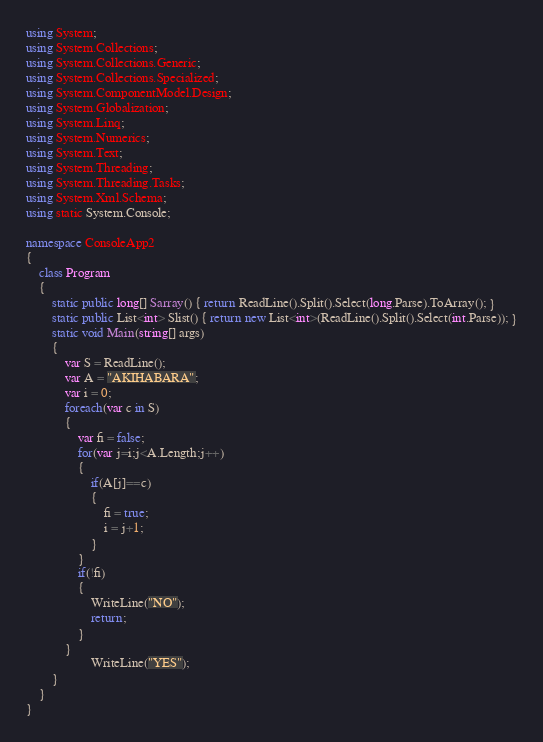<code> <loc_0><loc_0><loc_500><loc_500><_C#_>using System;
using System.Collections;
using System.Collections.Generic;
using System.Collections.Specialized;
using System.ComponentModel.Design;
using System.Globalization;
using System.Linq;
using System.Numerics;
using System.Text;
using System.Threading;
using System.Threading.Tasks;
using System.Xml.Schema;
using static System.Console;

namespace ConsoleApp2
{
    class Program
    {
        static public long[] Sarray() { return ReadLine().Split().Select(long.Parse).ToArray(); }
        static public List<int> Slist() { return new List<int>(ReadLine().Split().Select(int.Parse)); }
        static void Main(string[] args)
        {
            var S = ReadLine();
            var A = "AKIHABARA";
            var i = 0;
            foreach(var c in S)
            {
                var fi = false;
                for(var j=i;j<A.Length;j++)
                {
                    if(A[j]==c)
                    {
                        fi = true;
                        i = j+1;
                    }
                }
                if(!fi)
                {
                    WriteLine("NO");
                    return;
                }
            }
                    WriteLine("YES");
        }
    }
}</code> 